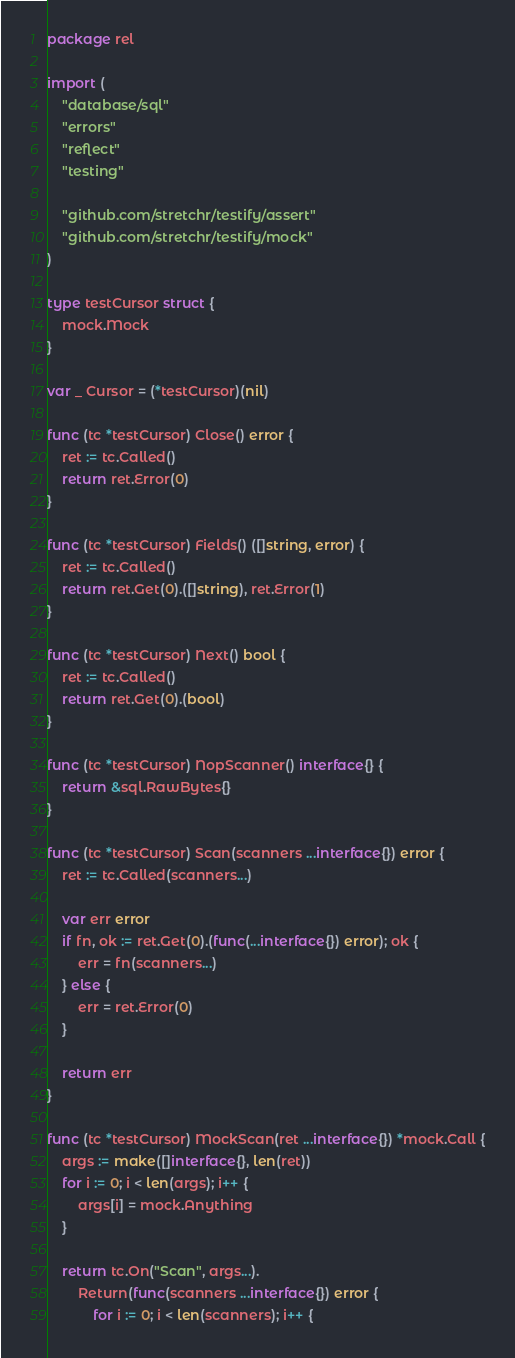Convert code to text. <code><loc_0><loc_0><loc_500><loc_500><_Go_>package rel

import (
	"database/sql"
	"errors"
	"reflect"
	"testing"

	"github.com/stretchr/testify/assert"
	"github.com/stretchr/testify/mock"
)

type testCursor struct {
	mock.Mock
}

var _ Cursor = (*testCursor)(nil)

func (tc *testCursor) Close() error {
	ret := tc.Called()
	return ret.Error(0)
}

func (tc *testCursor) Fields() ([]string, error) {
	ret := tc.Called()
	return ret.Get(0).([]string), ret.Error(1)
}

func (tc *testCursor) Next() bool {
	ret := tc.Called()
	return ret.Get(0).(bool)
}

func (tc *testCursor) NopScanner() interface{} {
	return &sql.RawBytes{}
}

func (tc *testCursor) Scan(scanners ...interface{}) error {
	ret := tc.Called(scanners...)

	var err error
	if fn, ok := ret.Get(0).(func(...interface{}) error); ok {
		err = fn(scanners...)
	} else {
		err = ret.Error(0)
	}

	return err
}

func (tc *testCursor) MockScan(ret ...interface{}) *mock.Call {
	args := make([]interface{}, len(ret))
	for i := 0; i < len(args); i++ {
		args[i] = mock.Anything
	}

	return tc.On("Scan", args...).
		Return(func(scanners ...interface{}) error {
			for i := 0; i < len(scanners); i++ {</code> 